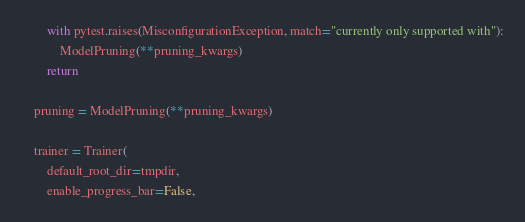Convert code to text. <code><loc_0><loc_0><loc_500><loc_500><_Python_>        with pytest.raises(MisconfigurationException, match="currently only supported with"):
            ModelPruning(**pruning_kwargs)
        return

    pruning = ModelPruning(**pruning_kwargs)

    trainer = Trainer(
        default_root_dir=tmpdir,
        enable_progress_bar=False,</code> 